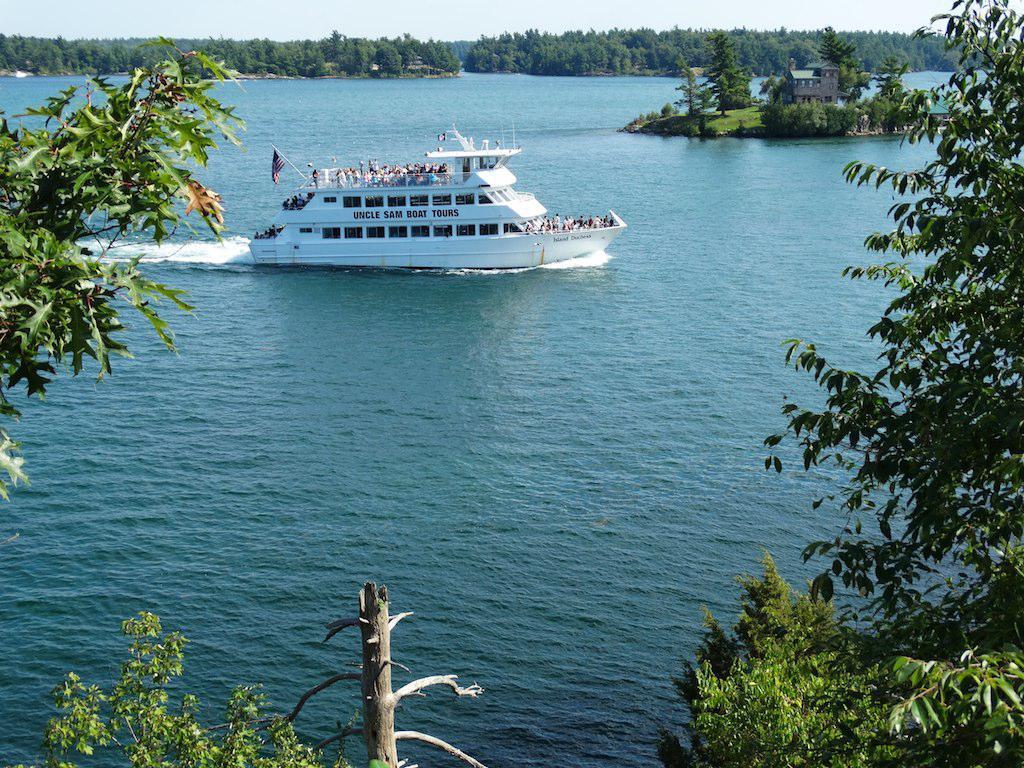Describe this image in one or two sentences. In this picture, we see water and this water might be in the sea. In the middle of the picture, we see a ship is sailing on the water. On either side of the picture, we see trees. At the bottom, we see the stem of the tree. There are trees and a hut in the background. At the top, we see the sky. 